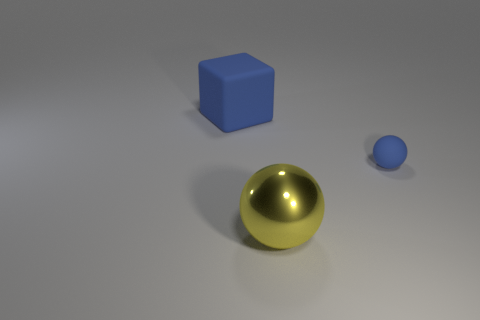Add 2 big matte things. How many objects exist? 5 Subtract all yellow spheres. How many spheres are left? 1 Subtract all spheres. How many objects are left? 1 Add 2 big gray metallic spheres. How many big gray metallic spheres exist? 2 Subtract 0 gray balls. How many objects are left? 3 Subtract all green balls. Subtract all red blocks. How many balls are left? 2 Subtract all cyan cylinders. How many blue balls are left? 1 Subtract all blue rubber blocks. Subtract all rubber objects. How many objects are left? 0 Add 3 rubber spheres. How many rubber spheres are left? 4 